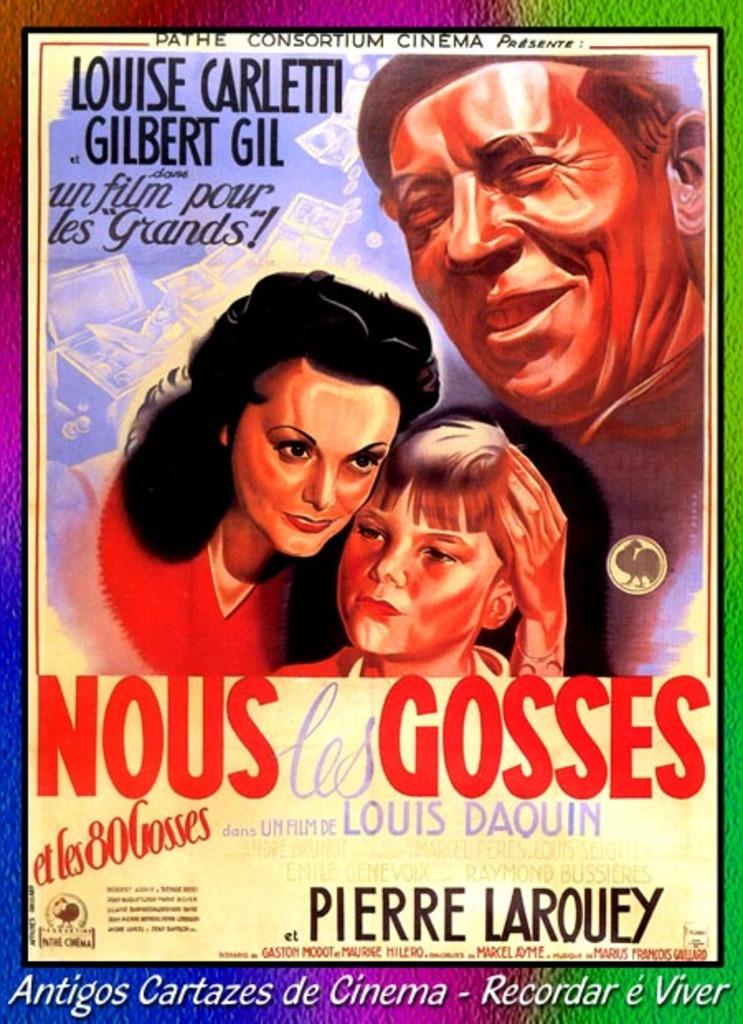<image>
Render a clear and concise summary of the photo. A poster for a old foreign movie called Nous Les Gosses which has a women, child and man on the poster. 